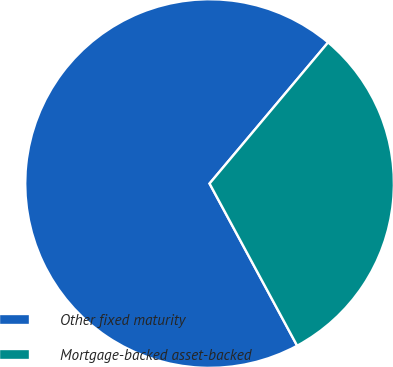Convert chart to OTSL. <chart><loc_0><loc_0><loc_500><loc_500><pie_chart><fcel>Other fixed maturity<fcel>Mortgage-backed asset-backed<nl><fcel>69.0%<fcel>31.0%<nl></chart> 